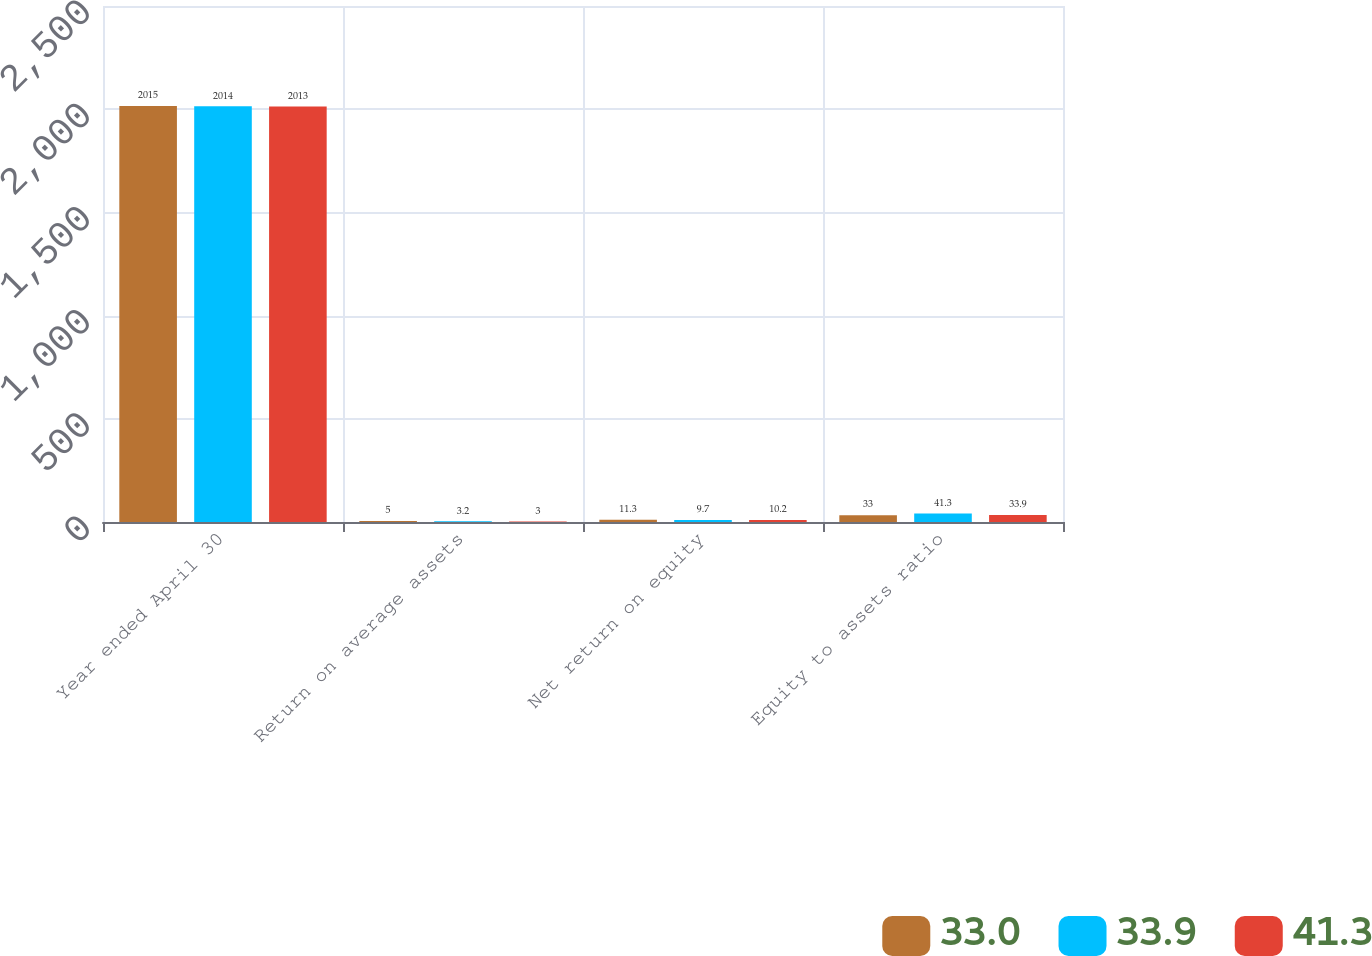Convert chart to OTSL. <chart><loc_0><loc_0><loc_500><loc_500><stacked_bar_chart><ecel><fcel>Year ended April 30<fcel>Return on average assets<fcel>Net return on equity<fcel>Equity to assets ratio<nl><fcel>33<fcel>2015<fcel>5<fcel>11.3<fcel>33<nl><fcel>33.9<fcel>2014<fcel>3.2<fcel>9.7<fcel>41.3<nl><fcel>41.3<fcel>2013<fcel>3<fcel>10.2<fcel>33.9<nl></chart> 